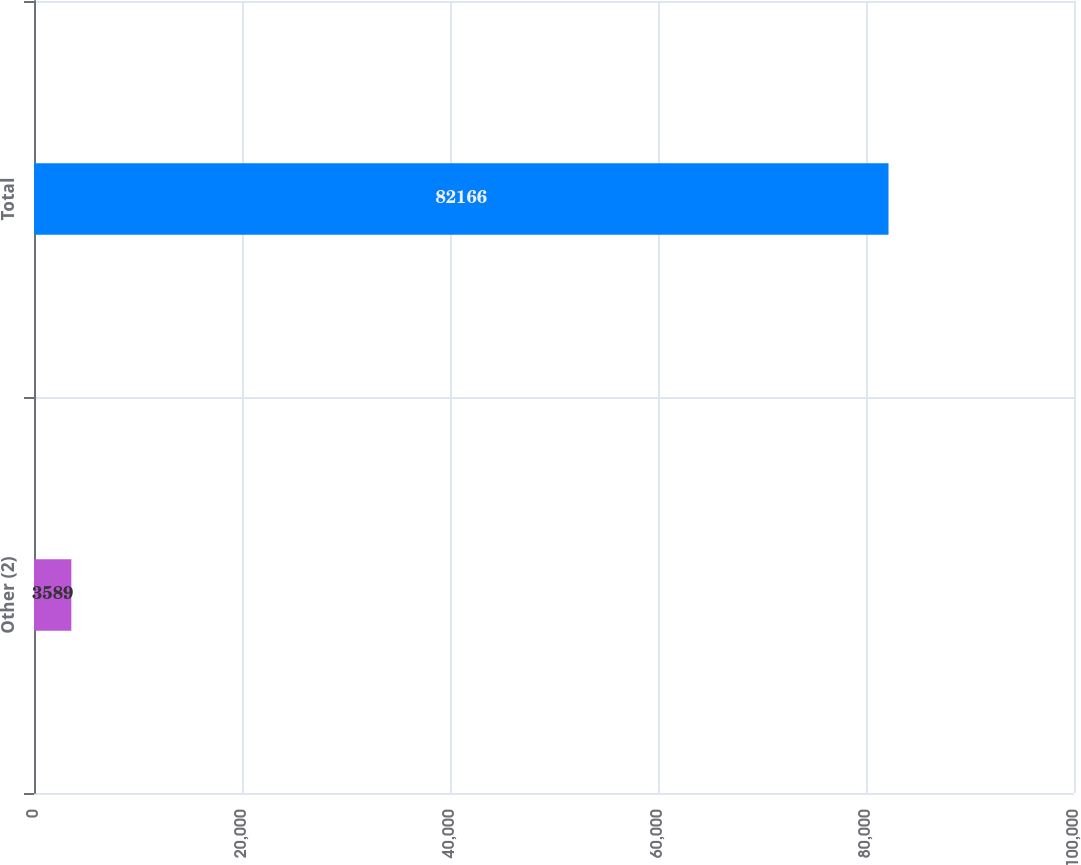Convert chart to OTSL. <chart><loc_0><loc_0><loc_500><loc_500><bar_chart><fcel>Other (2)<fcel>Total<nl><fcel>3589<fcel>82166<nl></chart> 